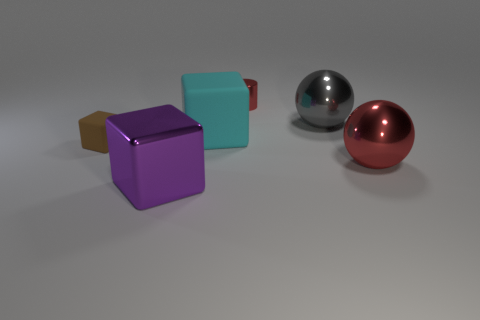What can you infer about the environment these objects are placed in? The environment appears to be a neutral, nondescript space with no distinctive features, likely a digital or controlled setting designed to focus attention solely on the objects themselves, highlighting their shapes and materials without external distractions. 